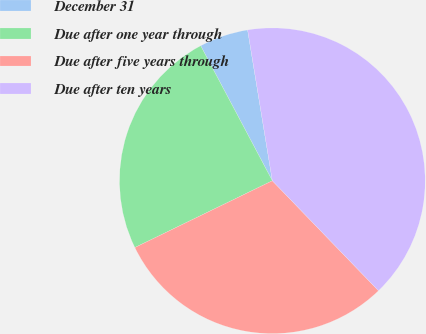Convert chart to OTSL. <chart><loc_0><loc_0><loc_500><loc_500><pie_chart><fcel>December 31<fcel>Due after one year through<fcel>Due after five years through<fcel>Due after ten years<nl><fcel>5.18%<fcel>24.43%<fcel>30.02%<fcel>40.37%<nl></chart> 